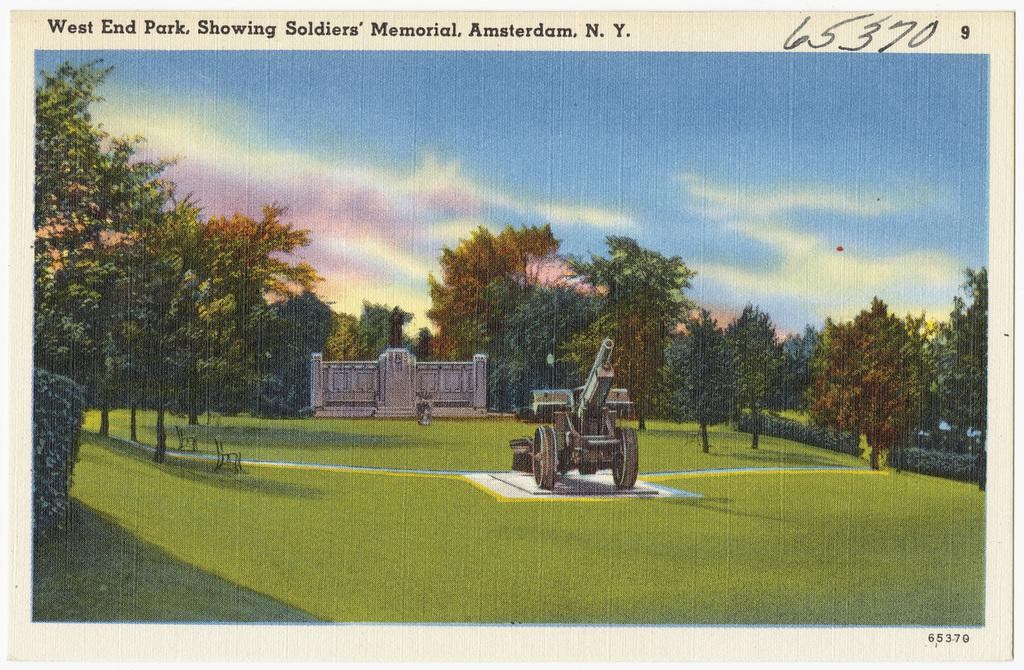What is depicted in the painting in the image? There is a painting of a building in the image. Are there any specific objects or features within the painting? Yes, there is a military tank and benches in the painting. What type of vegetation is present in the painting? There are trees in the painting. How is the sky depicted in the painting? The sky is clear in the painting. Is there any text or writing in the painting? Yes, there is something written at the top of the painting. What type of heat can be felt coming from the military tank in the painting? There is no indication of heat or temperature in the painting, and the military tank is a static object. What nation is depicted in the painting? The painting does not depict a specific nation; it is a painting of a building with a military tank and other elements. 